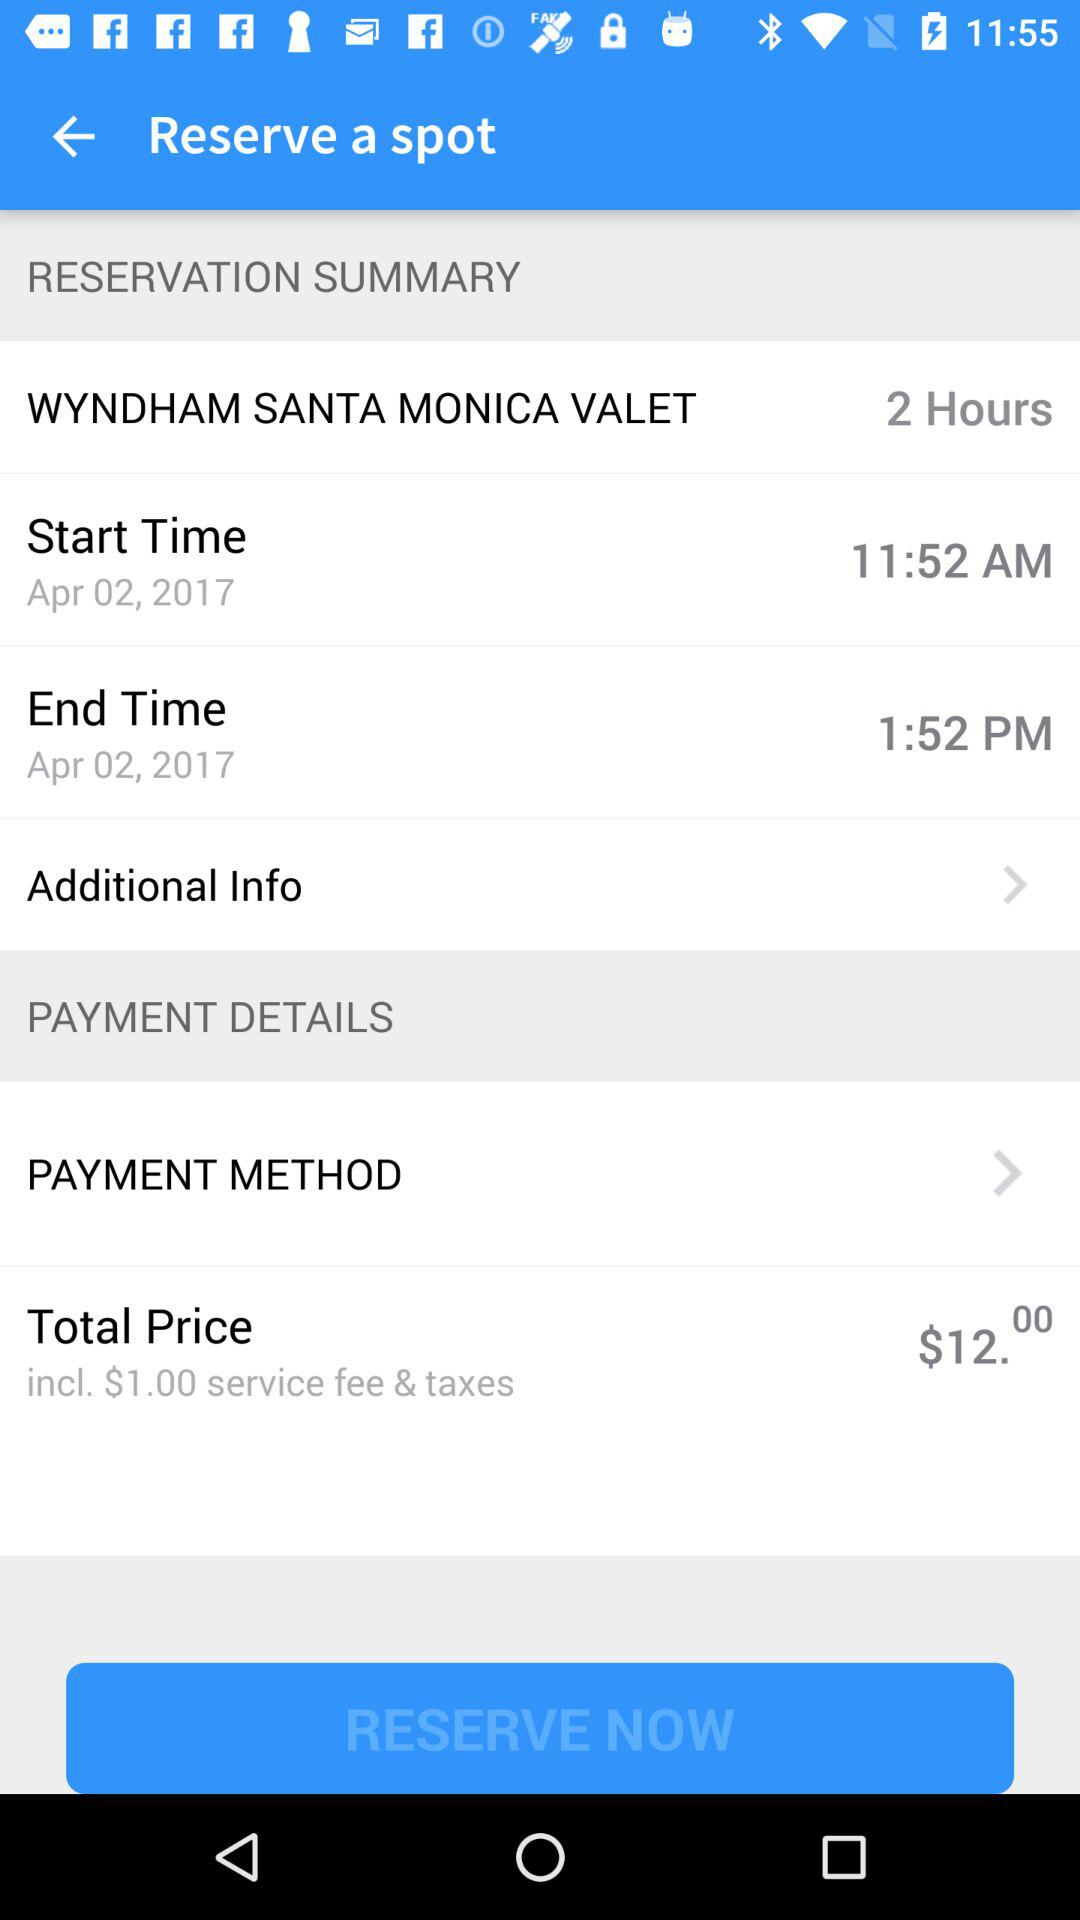What is the start and end time of the spot reserved at the Wyndham Santa Monica Valet? The start and end times are 11:52 AM and 1:52 PM respectively. 